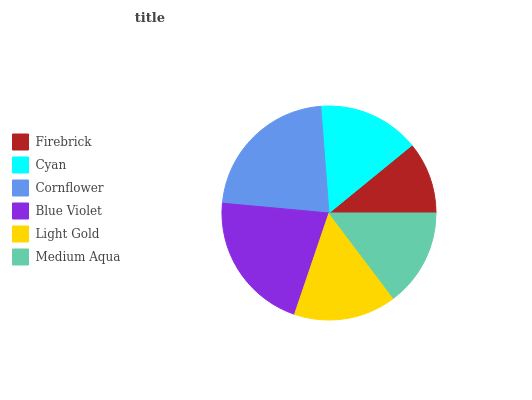Is Firebrick the minimum?
Answer yes or no. Yes. Is Cornflower the maximum?
Answer yes or no. Yes. Is Cyan the minimum?
Answer yes or no. No. Is Cyan the maximum?
Answer yes or no. No. Is Cyan greater than Firebrick?
Answer yes or no. Yes. Is Firebrick less than Cyan?
Answer yes or no. Yes. Is Firebrick greater than Cyan?
Answer yes or no. No. Is Cyan less than Firebrick?
Answer yes or no. No. Is Light Gold the high median?
Answer yes or no. Yes. Is Cyan the low median?
Answer yes or no. Yes. Is Cyan the high median?
Answer yes or no. No. Is Light Gold the low median?
Answer yes or no. No. 